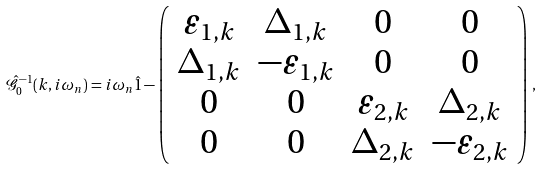<formula> <loc_0><loc_0><loc_500><loc_500>\hat { \mathcal { G } } _ { 0 } ^ { - 1 } ( k , i \omega _ { n } ) = i \omega _ { n } \hat { 1 } - \left ( \begin{array} { c c c c } \varepsilon _ { 1 , k } & \Delta _ { 1 , k } & 0 & 0 \\ \Delta _ { 1 , k } & - \varepsilon _ { 1 , k } & 0 & 0 \\ 0 & 0 & \varepsilon _ { 2 , k } & \Delta _ { 2 , k } \\ 0 & 0 & \Delta _ { 2 , k } & - \varepsilon _ { 2 , k } \end{array} \right ) \, ,</formula> 